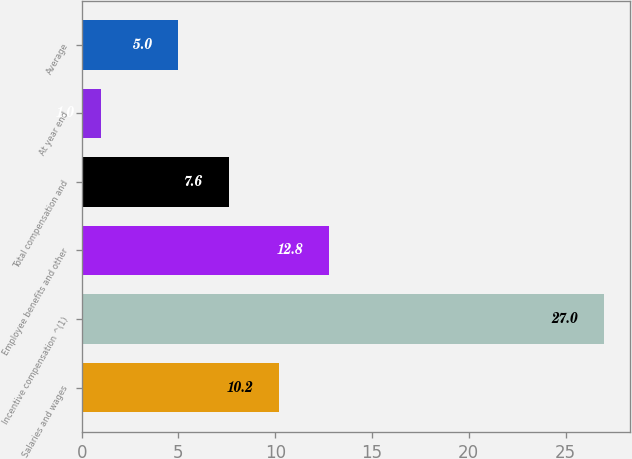Convert chart to OTSL. <chart><loc_0><loc_0><loc_500><loc_500><bar_chart><fcel>Salaries and wages<fcel>Incentive compensation ^(1)<fcel>Employee benefits and other<fcel>Total compensation and<fcel>At year end<fcel>Average<nl><fcel>10.2<fcel>27<fcel>12.8<fcel>7.6<fcel>1<fcel>5<nl></chart> 